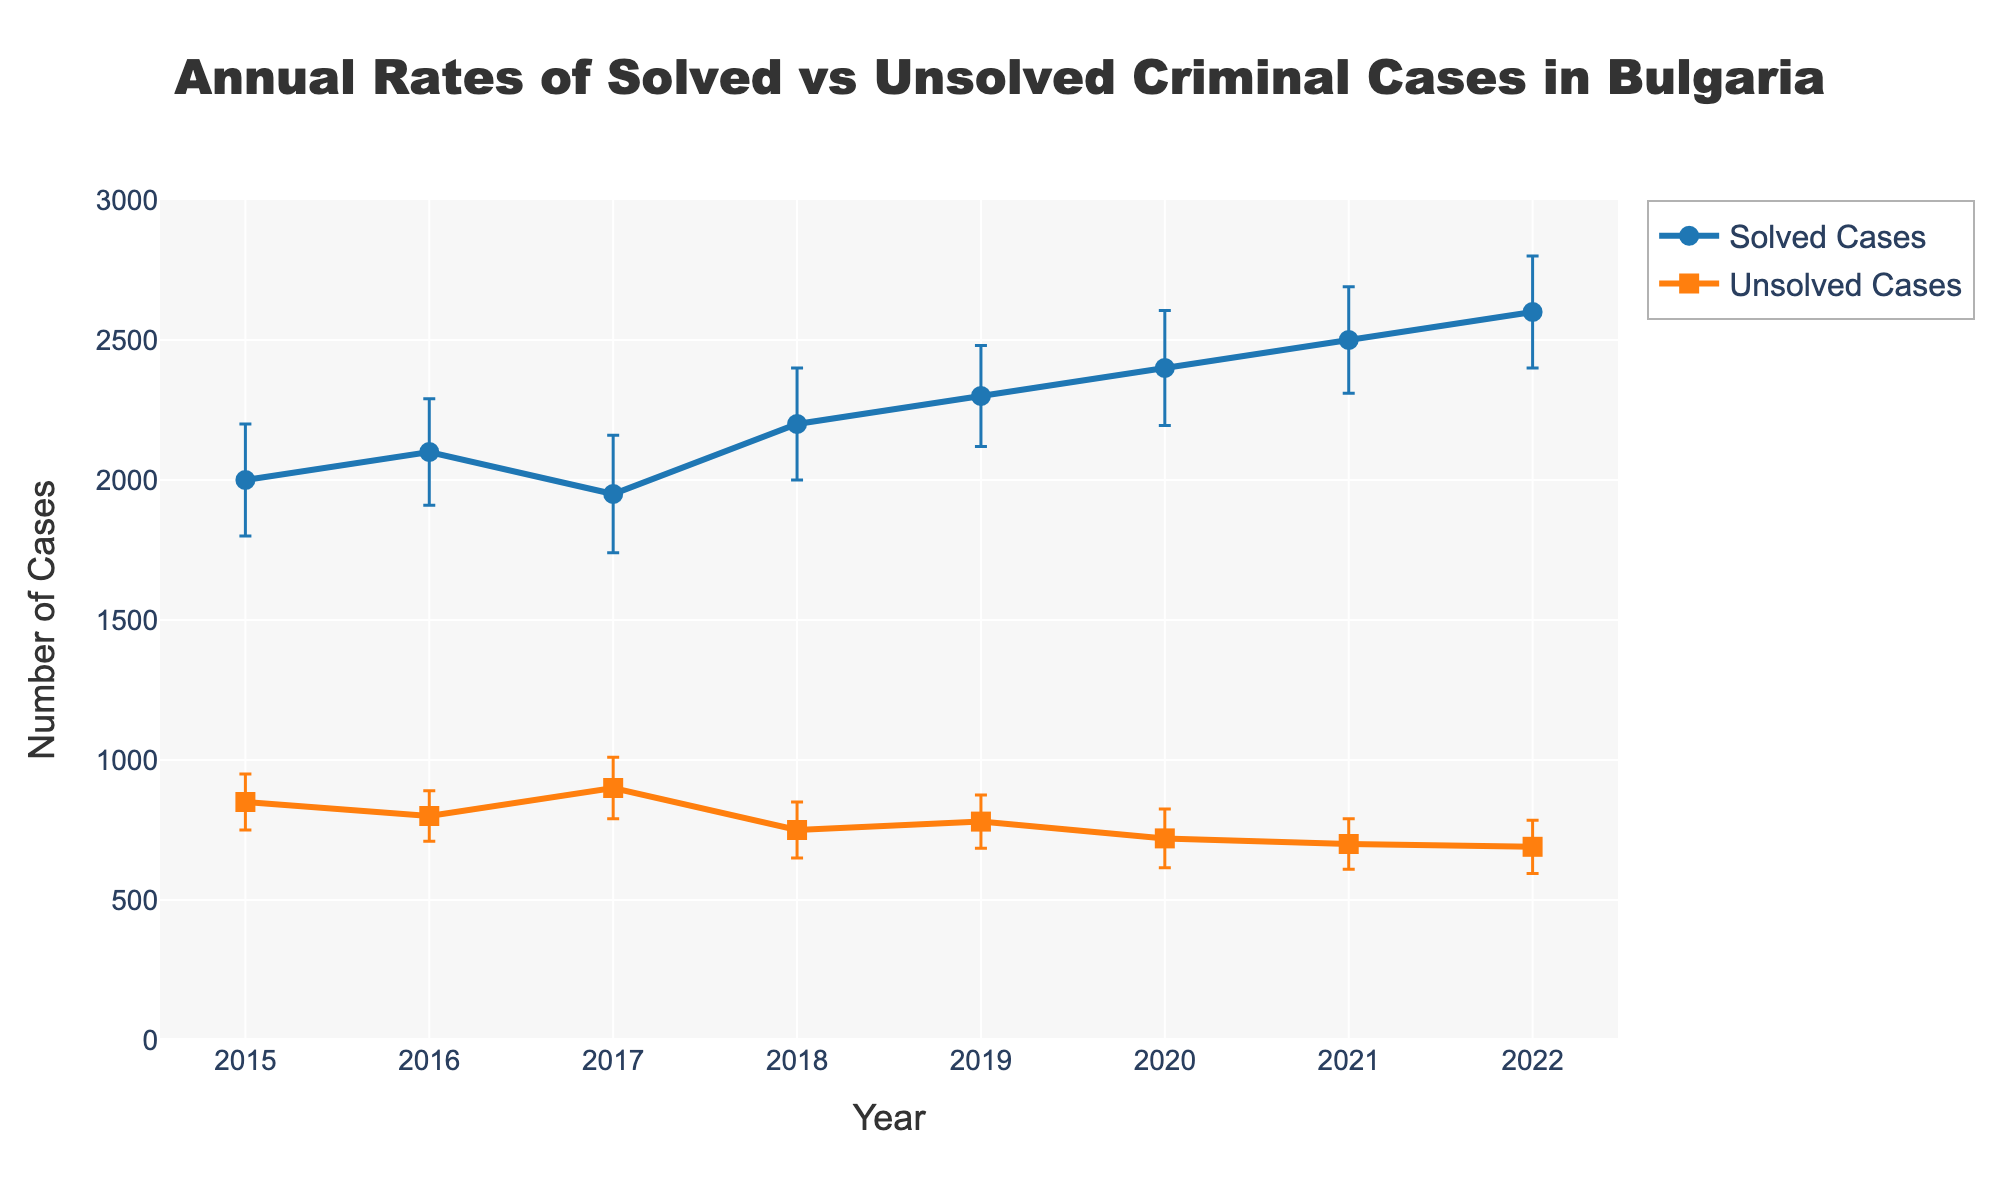What is the title of the plot? The title of the plot is displayed prominently at the top center. It reads "Annual Rates of Solved vs Unsolved Criminal Cases in Bulgaria".
Answer: Annual Rates of Solved vs Unsolved Criminal Cases in Bulgaria Which year had the highest number of solved cases? Observing the line representing solved cases, the highest point on the y-axis corresponds to the year 2022, where solved cases reached 2600.
Answer: 2022 What is the range of the y-axis? The y-axis, which indicates the number of cases, ranges from 0 to 3000. This can be seen by the labeled ticks along the y-axis.
Answer: 0 to 3000 How many data points are represented for both solved and unsolved cases? Each year from 2015 to 2022 has a data point for both solved and unsolved cases. Counting these points along the x-axis, we find there are eight data points for each category.
Answer: 8 What was the number of unsolved cases in 2019? To find the number, locate the year 2019 along the x-axis and trace upwards to the orange line representing unsolved cases. The corresponding y-value is approximately 780.
Answer: 780 How does the trend of solved cases compare to unsolved cases from 2015 to 2022? Observing the lines, solved cases have a general upward trend, whilst unsolved cases show a slight downward trend over the years. This indicates an increase in solved cases and a decrease in unsolved cases over time.
Answer: Solved cases increased, unsolved cases decreased By how many cases did the number of solved cases increase from 2015 to 2022? The number of solved cases in 2015 was 2000, and in 2022 it was 2600. The difference is calculated as 2600 - 2000 = 600.
Answer: 600 In which year did the solved and unsolved cases have the smallest difference? Comparing the gaps between the two lines for each year, 2017 appears to have the smallest difference. Visually, this is where the lines for solved and unsolved cases are closest.
Answer: 2017 What is the maximum margin of error for solved cases, and in which year does it occur? The error bars' vertical lengths signify the margin of error. The longest error bar for solved cases is in 2017, with an error margin of 210.
Answer: 210 in 2017 Considering the error margins, which year has the most overlapping error bars between solved and unsolved cases? The uncertainty represented by the error bars for both solved and unsolved cases seems to overlap most significantly in 2020, indicating more ambiguity in distinguishing between the two that year.
Answer: 2020 